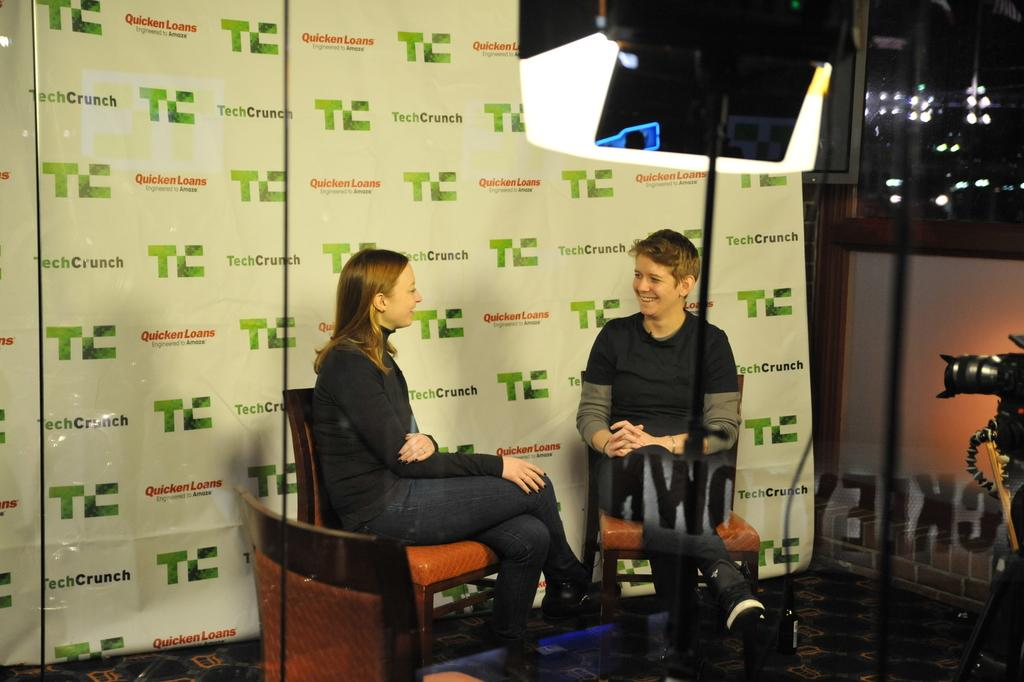Who are the people in the image? There is a girl and a boy in the image. What are the girl and boy doing in the image? The girl and boy are sitting on a chair and talking to each other. What object can be seen in the image that is used for capturing images? There is a camera in the image. What type of pickle is the girl holding in the image? There is no pickle present in the image; the girl and boy are sitting on a chair and talking to each other. What fruit can be seen in the image? There is no fruit present in the image. 